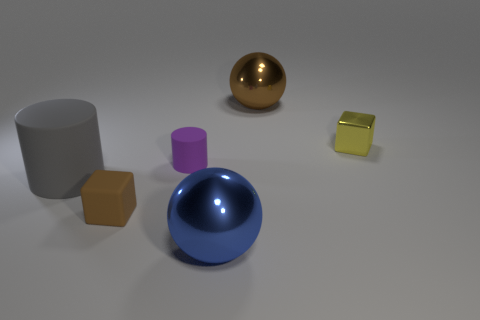Is the number of purple rubber objects greater than the number of small yellow cylinders?
Offer a terse response. Yes. How many other things are there of the same color as the small cylinder?
Provide a succinct answer. 0. How many things are large rubber cubes or big brown shiny spheres?
Ensure brevity in your answer.  1. There is a big object that is in front of the tiny brown rubber object; is it the same shape as the large brown object?
Your response must be concise. Yes. What is the color of the big sphere that is in front of the block that is left of the small purple matte thing?
Give a very brief answer. Blue. Are there fewer brown metal objects than metallic spheres?
Make the answer very short. Yes. Are there any brown balls that have the same material as the blue sphere?
Provide a succinct answer. Yes. Do the large blue shiny object and the large shiny object behind the small rubber block have the same shape?
Your answer should be compact. Yes. Are there any tiny purple rubber things right of the large matte cylinder?
Give a very brief answer. Yes. What number of tiny purple objects have the same shape as the blue thing?
Provide a succinct answer. 0. 